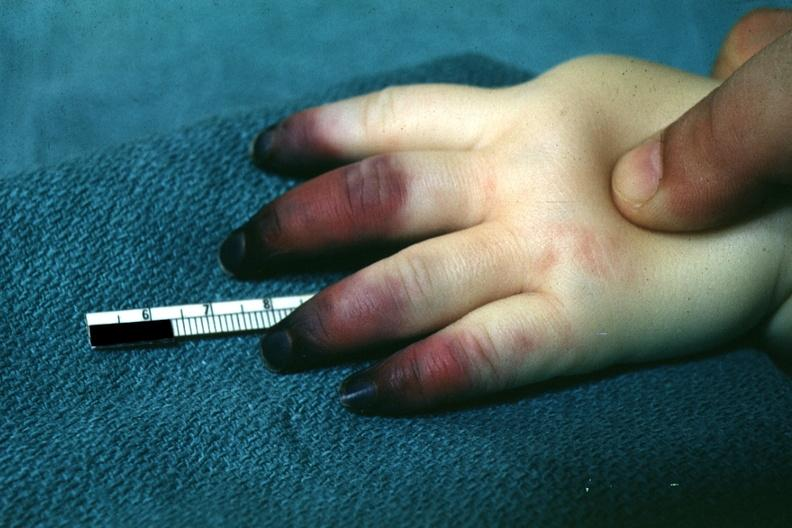what is present?
Answer the question using a single word or phrase. Acrocyanosis 